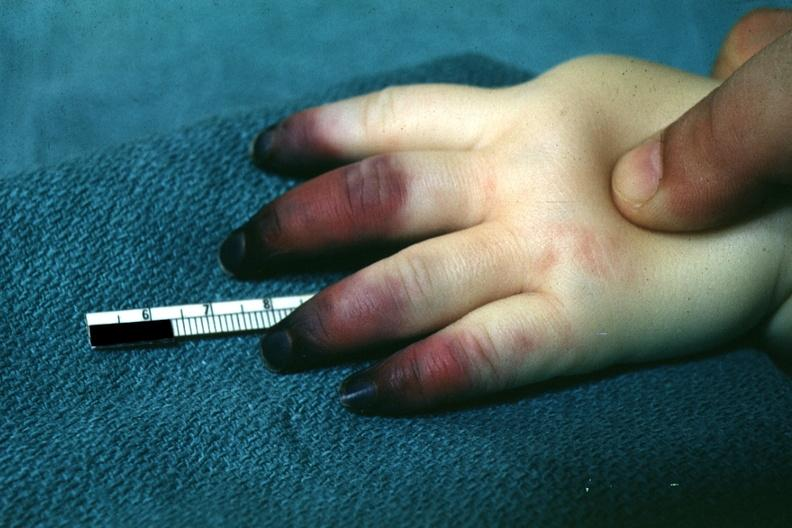what is present?
Answer the question using a single word or phrase. Acrocyanosis 